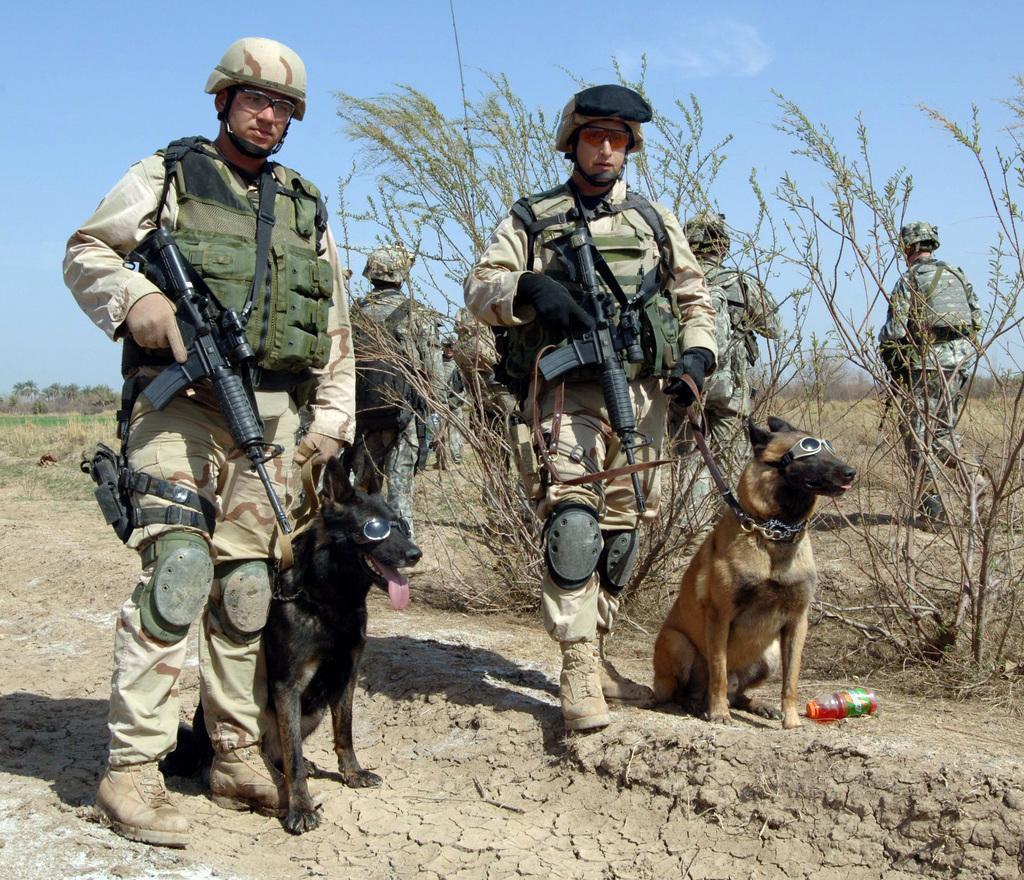Please provide a concise description of this image. In this picture we can see a group of people, dogs on the ground, they are wearing helmets and some people are holding guns, some people are wearing bags, here we can see a bottle, trees and we can see sky in the background. 